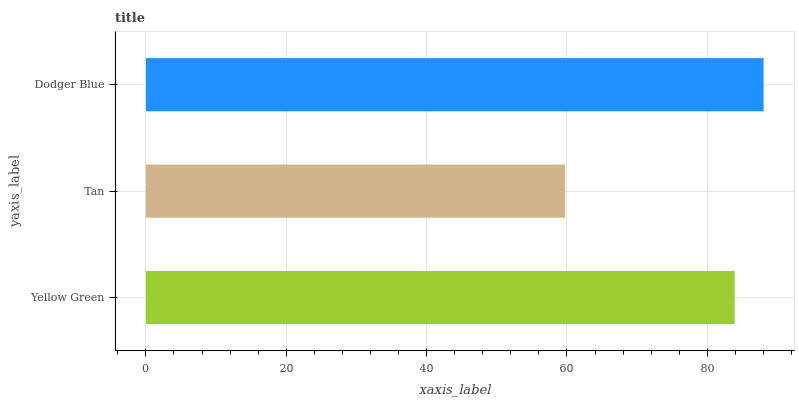Is Tan the minimum?
Answer yes or no. Yes. Is Dodger Blue the maximum?
Answer yes or no. Yes. Is Dodger Blue the minimum?
Answer yes or no. No. Is Tan the maximum?
Answer yes or no. No. Is Dodger Blue greater than Tan?
Answer yes or no. Yes. Is Tan less than Dodger Blue?
Answer yes or no. Yes. Is Tan greater than Dodger Blue?
Answer yes or no. No. Is Dodger Blue less than Tan?
Answer yes or no. No. Is Yellow Green the high median?
Answer yes or no. Yes. Is Yellow Green the low median?
Answer yes or no. Yes. Is Tan the high median?
Answer yes or no. No. Is Tan the low median?
Answer yes or no. No. 